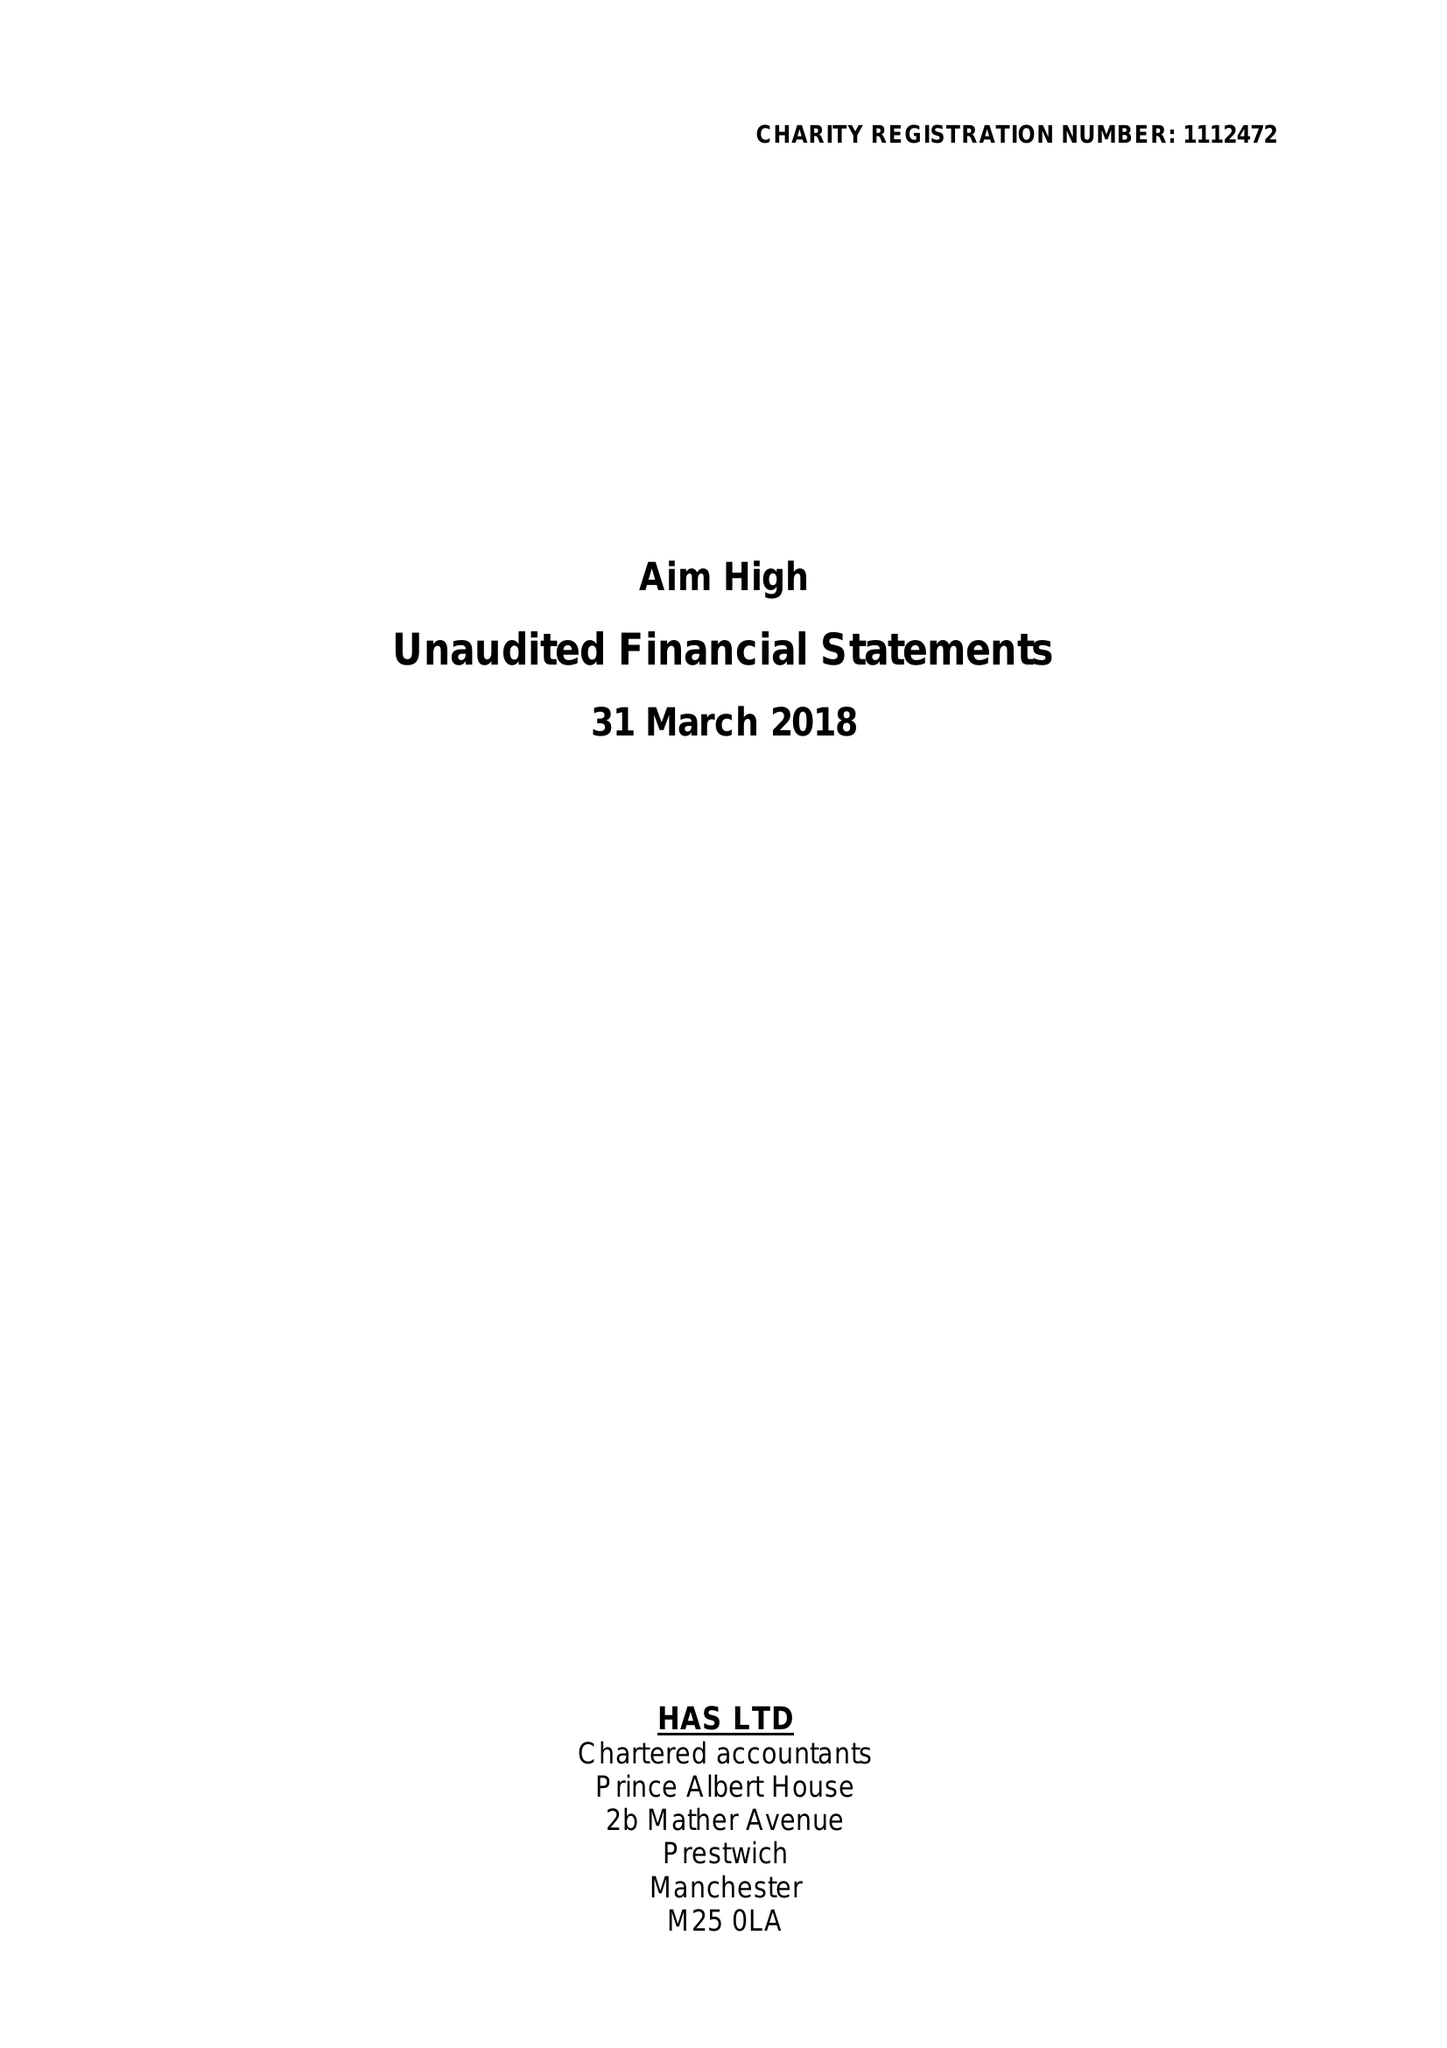What is the value for the address__street_line?
Answer the question using a single word or phrase. 33 KINGS ROAD 